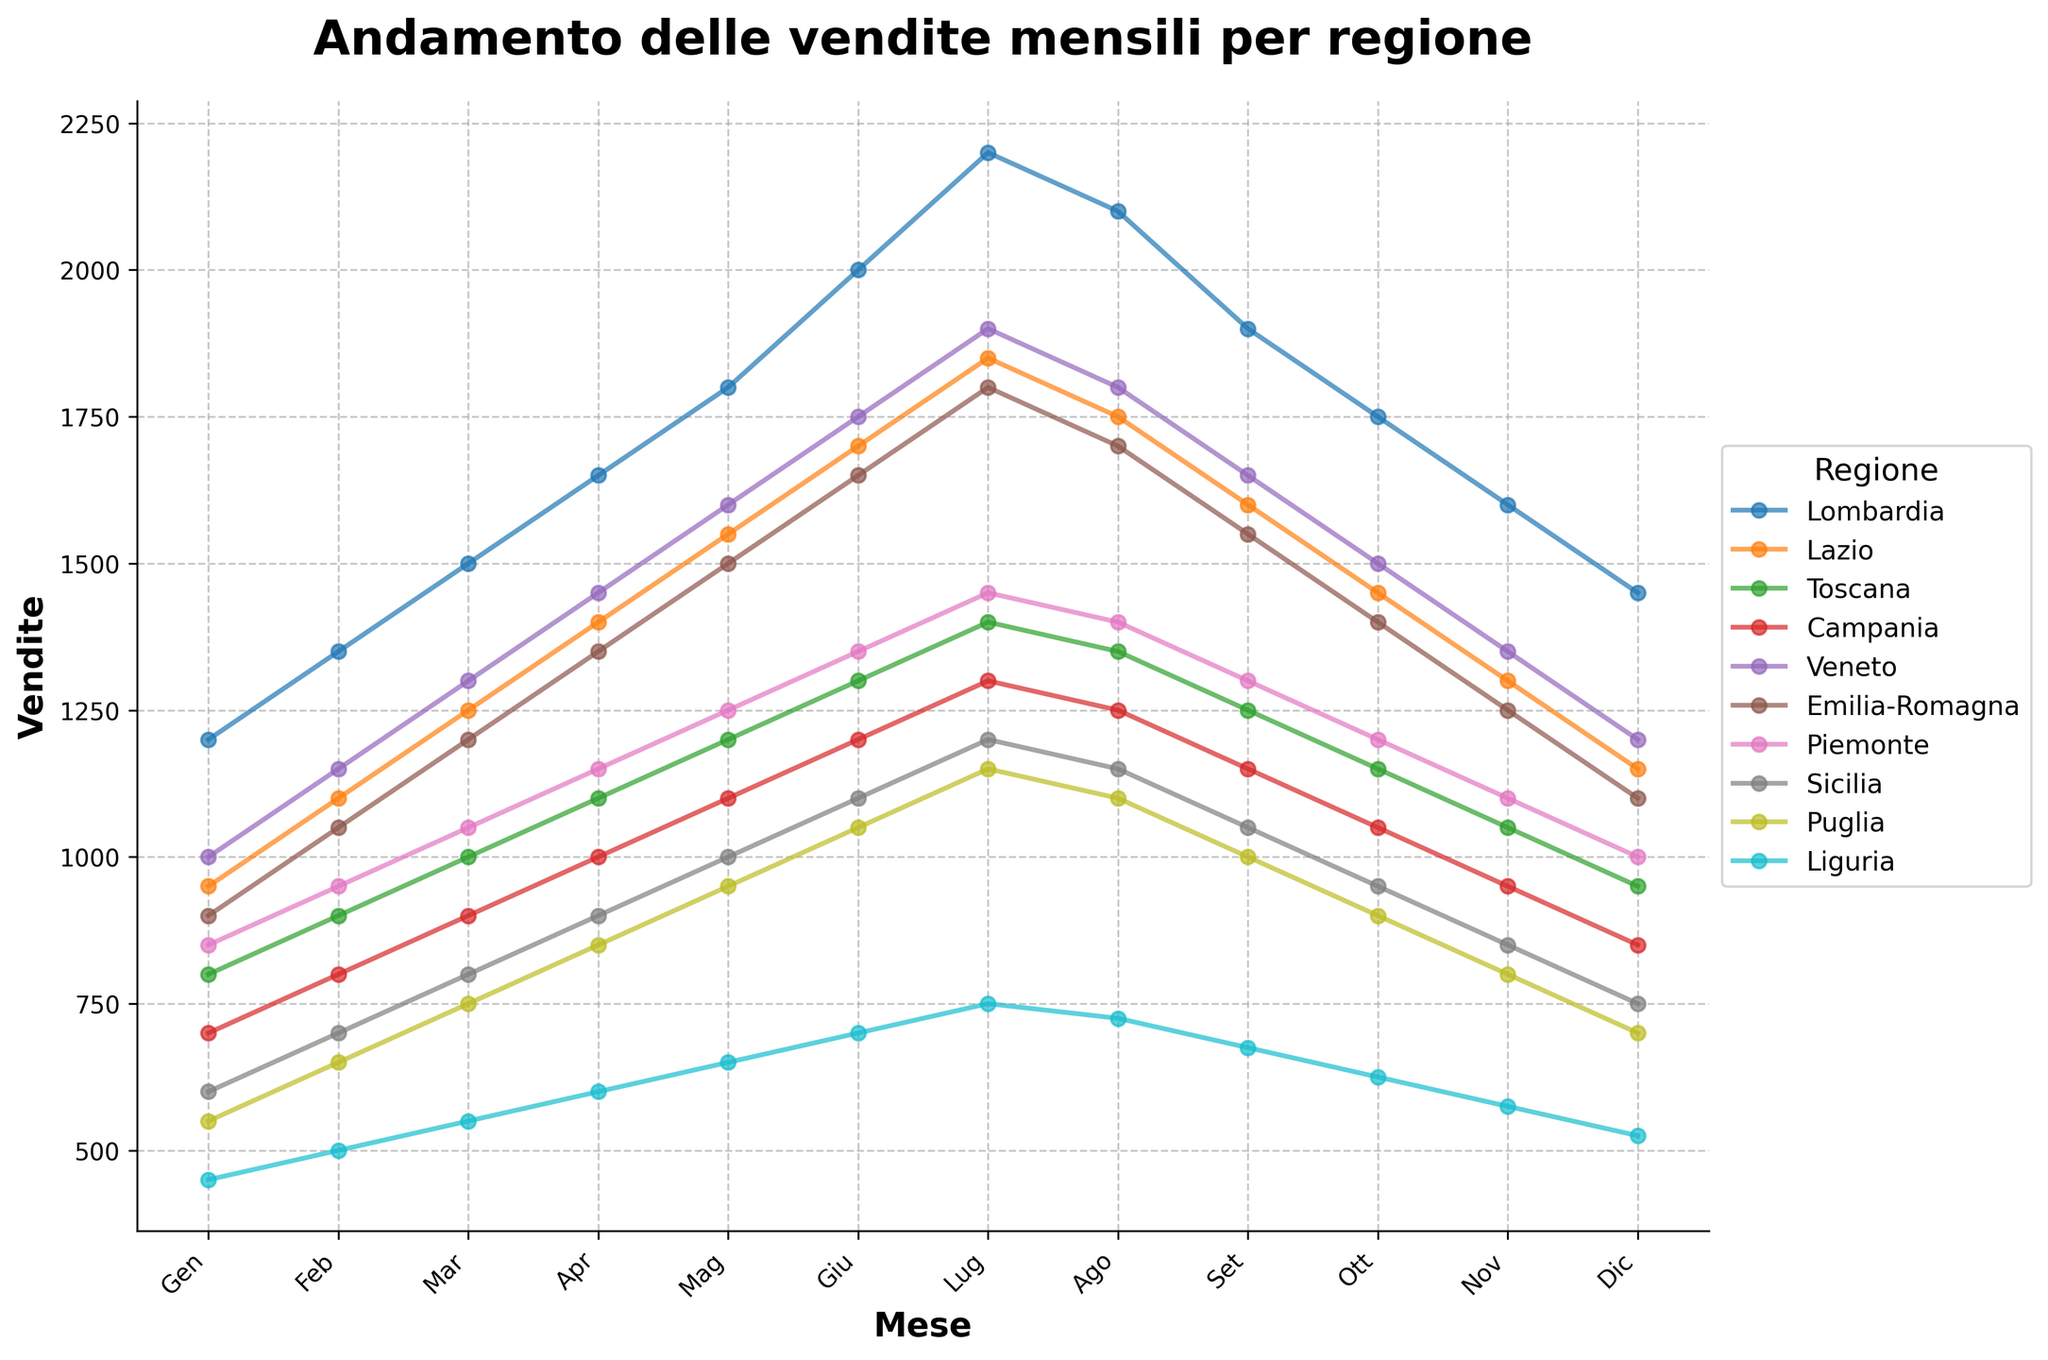What's the region with the highest sales in July? To find the region with the highest sales in July, look at the value corresponding to "Lug" (July) for each region and identify the highest value. The highest sales in July are in the Lombardia region with a sales value of 2200.
Answer: Lombardia Which region showed the most significant increase in sales from January to June? Calculate the difference between June ("Giu") and January ("Gen") sales for each region and find the highest difference. The region with the most significant increase is Lombardia with an increase of 800.
Answer: Lombardia In which month did Sicilia have the lowest sales, and what was the value? Look at the sales values for each month in Sicilia and identify the lowest value. The lowest sales for Sicilia occurred in December with a value of 750.
Answer: December, 750 Compare the sales trend between Piemonte and Emilia-Romagna in the second half of the year. Which region had more stable sales? Examining the sales from July ("Lug") to December ("Dic") for both regions, Piemonte shows a more stable trend as the differences between months are smaller compared to Emilia-Romagna.
Answer: Piemonte What's the average sales value for Veneto over the year? Sum the monthly sales values for Veneto and divide by 12. \( \text{Total sales} = 1000 + 1150 + 1300 + 1450 + 1600 + 1750 + 1900 + 1800 + 1650 + 1500 + 1350 + 1200 = 18650 \). The average sales value is \( \frac{18650}{12} \approx 1554.17 \).
Answer: 1554.17 Which two regions have the closest sales values in August? Look at the sales values in August ("Ago") for each region and find the two with the smallest difference. Sicilia and Puglia have the closest sales values of 1150 and 1100, respectively, with a difference of 50.
Answer: Sicilia and Puglia What's the total sales in December for all regions combined? Add the sales values for each region in December ("Dic"). \( 1450 + 1150 + 950 + 850 + 1200 + 1100 + 1000 + 750 + 700 + 525 = 9675 \). The total sales in December for all regions is 9675.
Answer: 9675 Identify the region with the most sales fluctuations throughout the year. How did you determine it? Identify the region with the highest range between its maximum and minimum monthly sales values. Calculate the range for each region: Lombardia (2200-1200=1000), Lazio (1850-950=900), etc. The region with the highest fluctuation is Lombardia with a range of 1000.
Answer: Lombardia Which month had the lowest overall sales across all regions, and what was the total for that month? Sum the sales for each region for each month and identify the month with the lowest total. December has the lowest overall sales. \( 1450 + 1150 + 950 + 850 + 1200 + 1100 + 1000 + 750 + 700 + 525 = 9675 \).
Answer: December, 9675 What is the general trend of sales in Liguria through the year? Observe the sales data for Liguria from January to December. Note that the sales generally show a steady increase from January to July and then a steady decrease from August to December.
Answer: Increase then decrease 